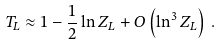Convert formula to latex. <formula><loc_0><loc_0><loc_500><loc_500>T _ { L } \approx 1 - \frac { 1 } { 2 } \ln Z _ { L } + O \left ( \ln ^ { 3 } Z _ { L } \right ) \, .</formula> 